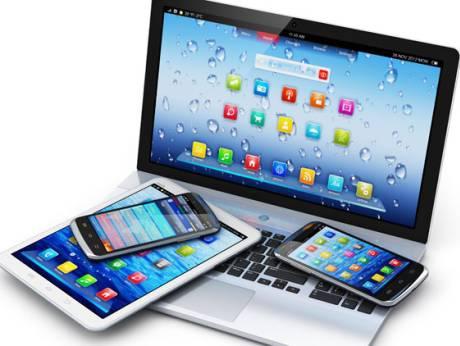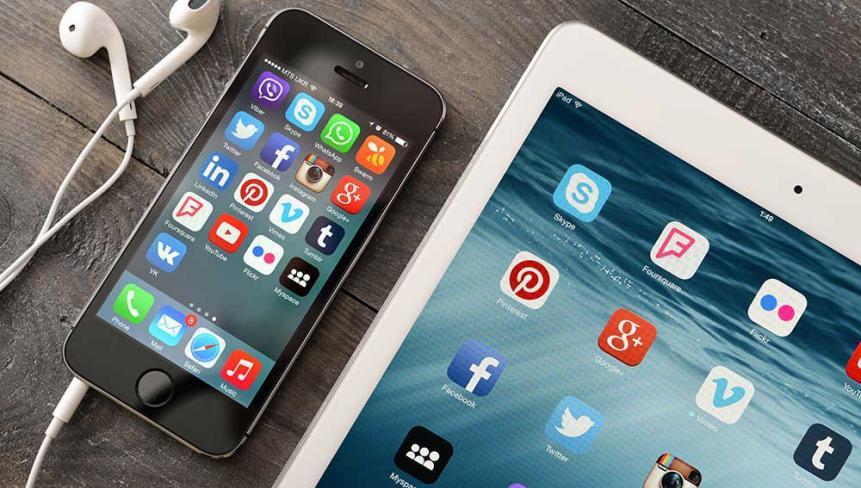The first image is the image on the left, the second image is the image on the right. Evaluate the accuracy of this statement regarding the images: "A smartphone and a tablet are laying on top of a laptop keyboard.". Is it true? Answer yes or no. Yes. The first image is the image on the left, the second image is the image on the right. Assess this claim about the two images: "One image includes a phone resting on a keyboard and near a device with a larger screen rimmed in white.". Correct or not? Answer yes or no. Yes. 